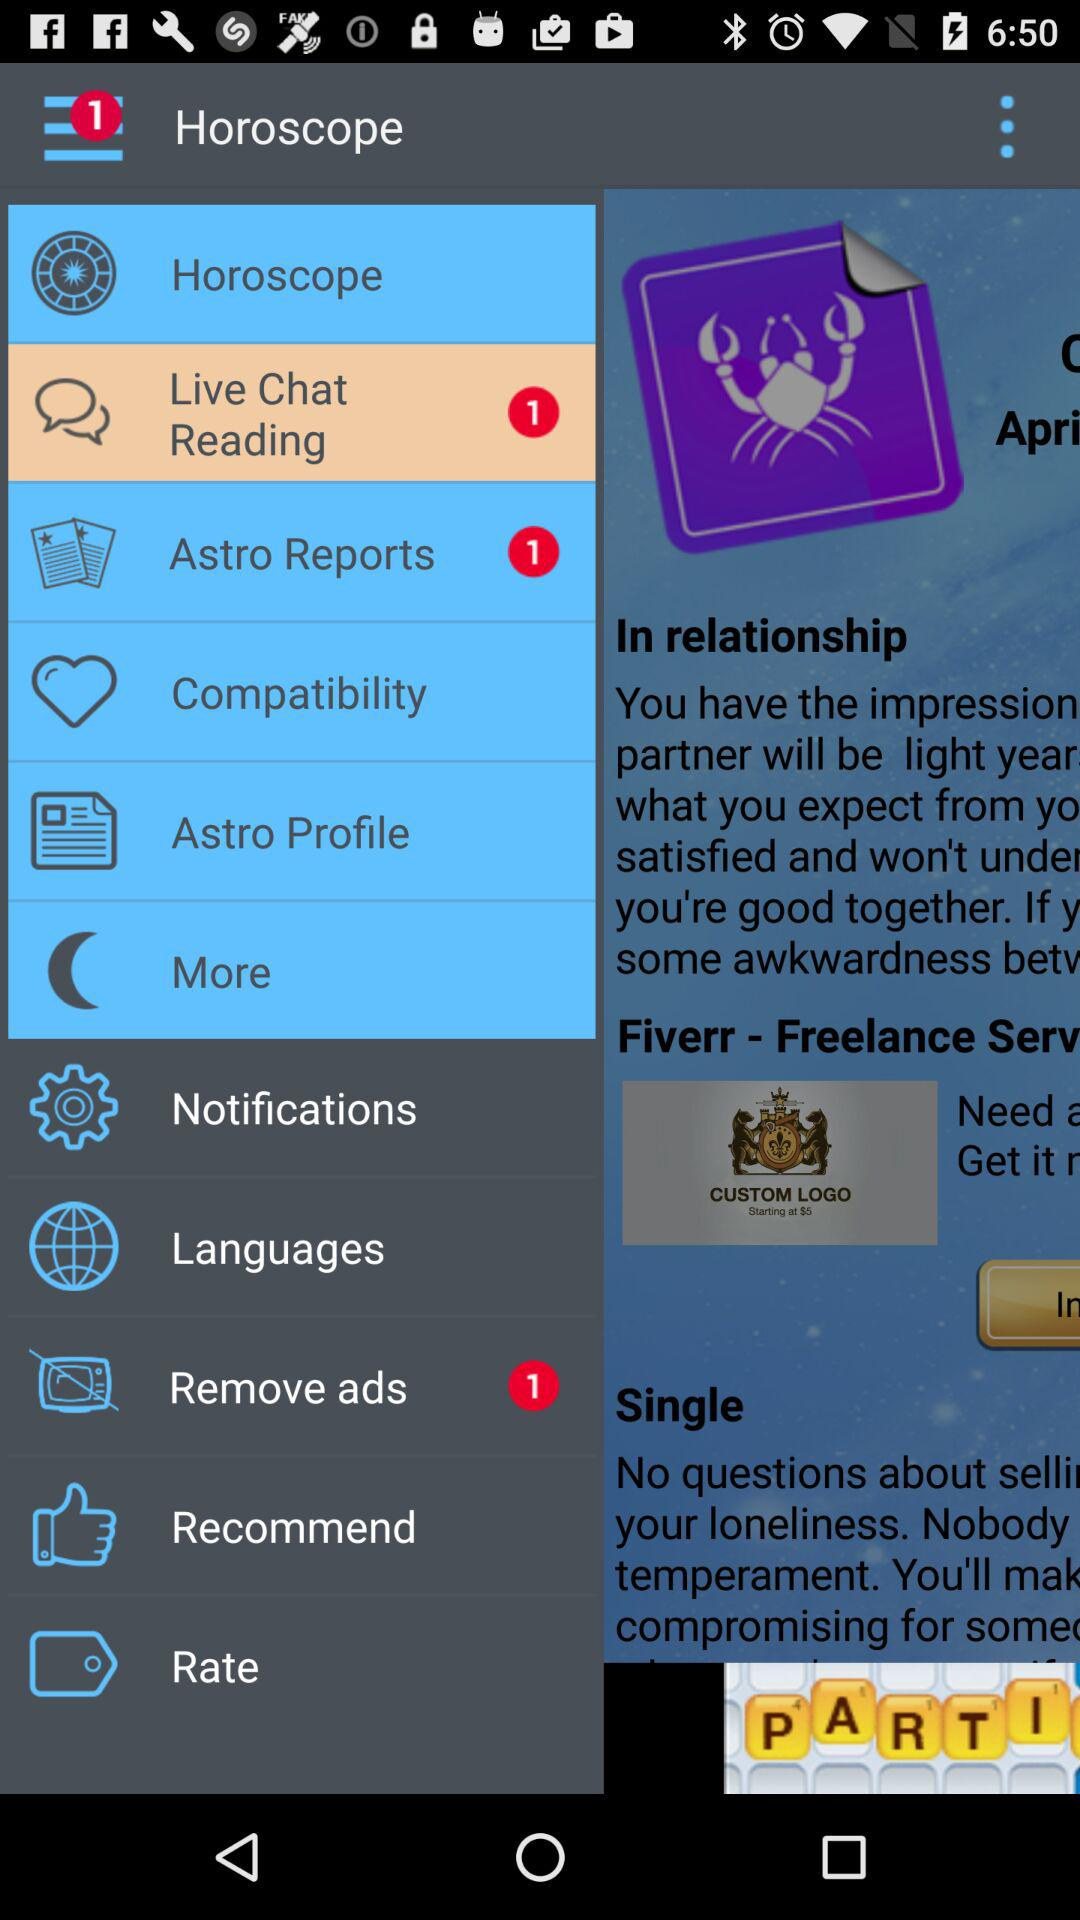Is there any unread "Live Chat Reading"? There is 1 unread "Live Chat Reading". 